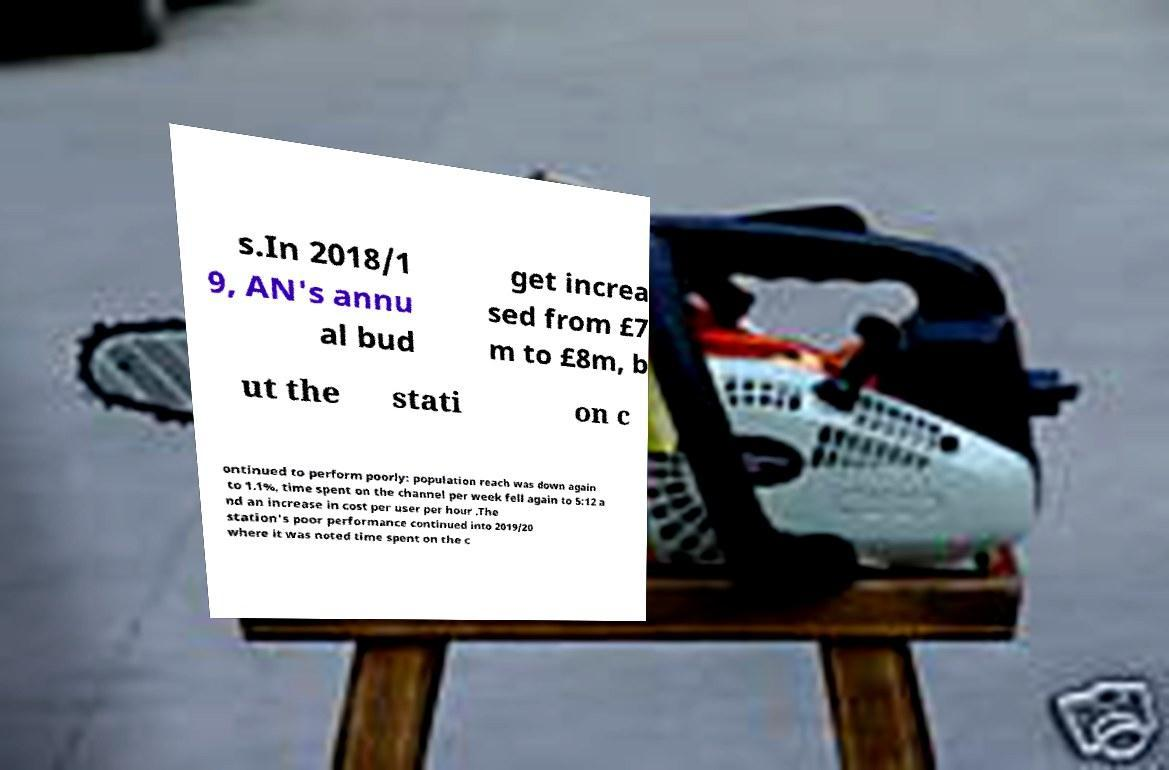For documentation purposes, I need the text within this image transcribed. Could you provide that? s.In 2018/1 9, AN's annu al bud get increa sed from £7 m to £8m, b ut the stati on c ontinued to perform poorly: population reach was down again to 1.1%, time spent on the channel per week fell again to 5:12 a nd an increase in cost per user per hour .The station's poor performance continued into 2019/20 where it was noted time spent on the c 